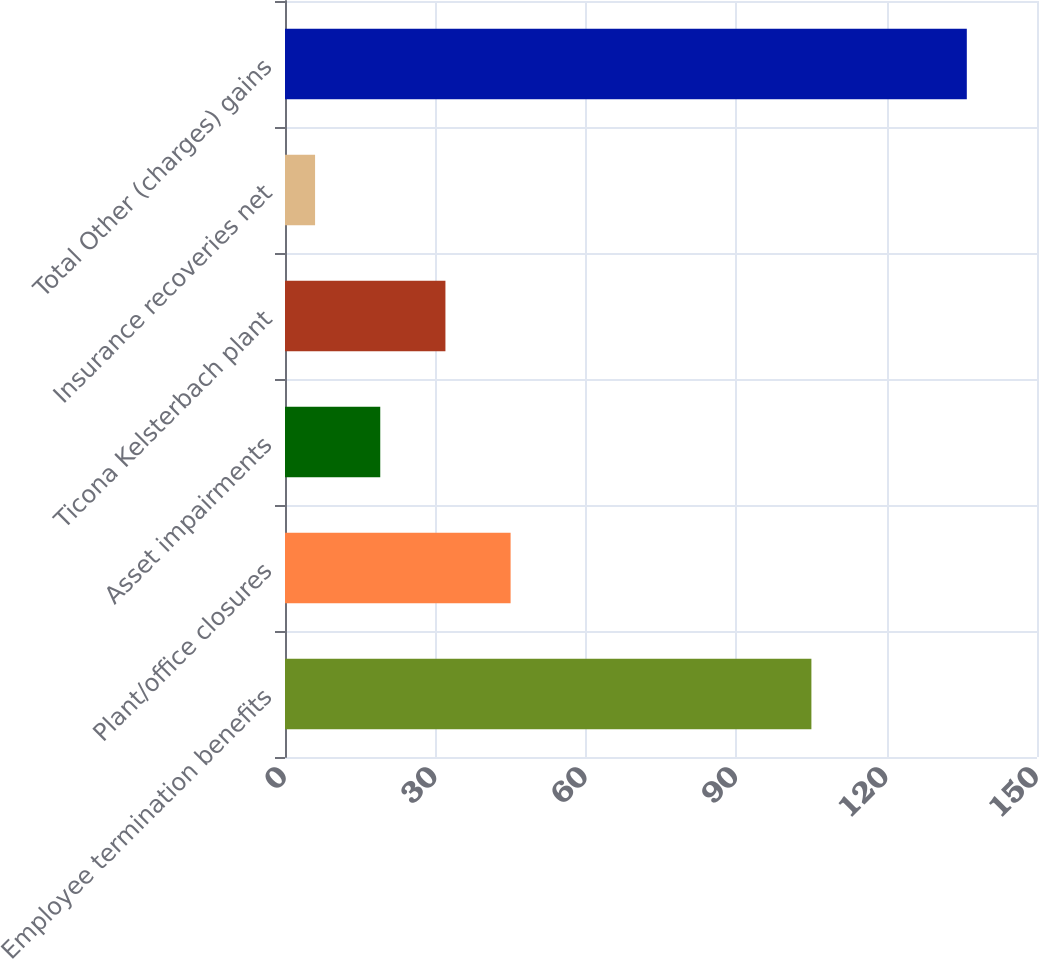Convert chart. <chart><loc_0><loc_0><loc_500><loc_500><bar_chart><fcel>Employee termination benefits<fcel>Plant/office closures<fcel>Asset impairments<fcel>Ticona Kelsterbach plant<fcel>Insurance recoveries net<fcel>Total Other (charges) gains<nl><fcel>105<fcel>45<fcel>19<fcel>32<fcel>6<fcel>136<nl></chart> 